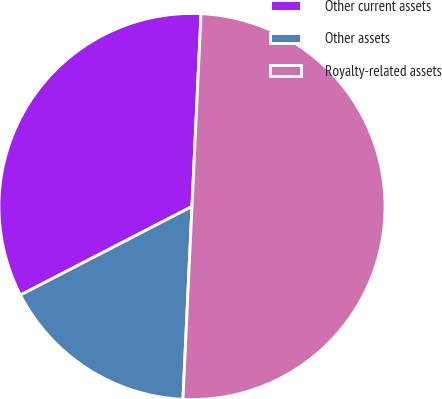<chart> <loc_0><loc_0><loc_500><loc_500><pie_chart><fcel>Other current assets<fcel>Other assets<fcel>Royalty-related assets<nl><fcel>33.33%<fcel>16.67%<fcel>50.0%<nl></chart> 